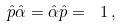<formula> <loc_0><loc_0><loc_500><loc_500>\hat { p } \hat { \alpha } = \hat { \alpha } \hat { p } = \ 1 \, ,</formula> 